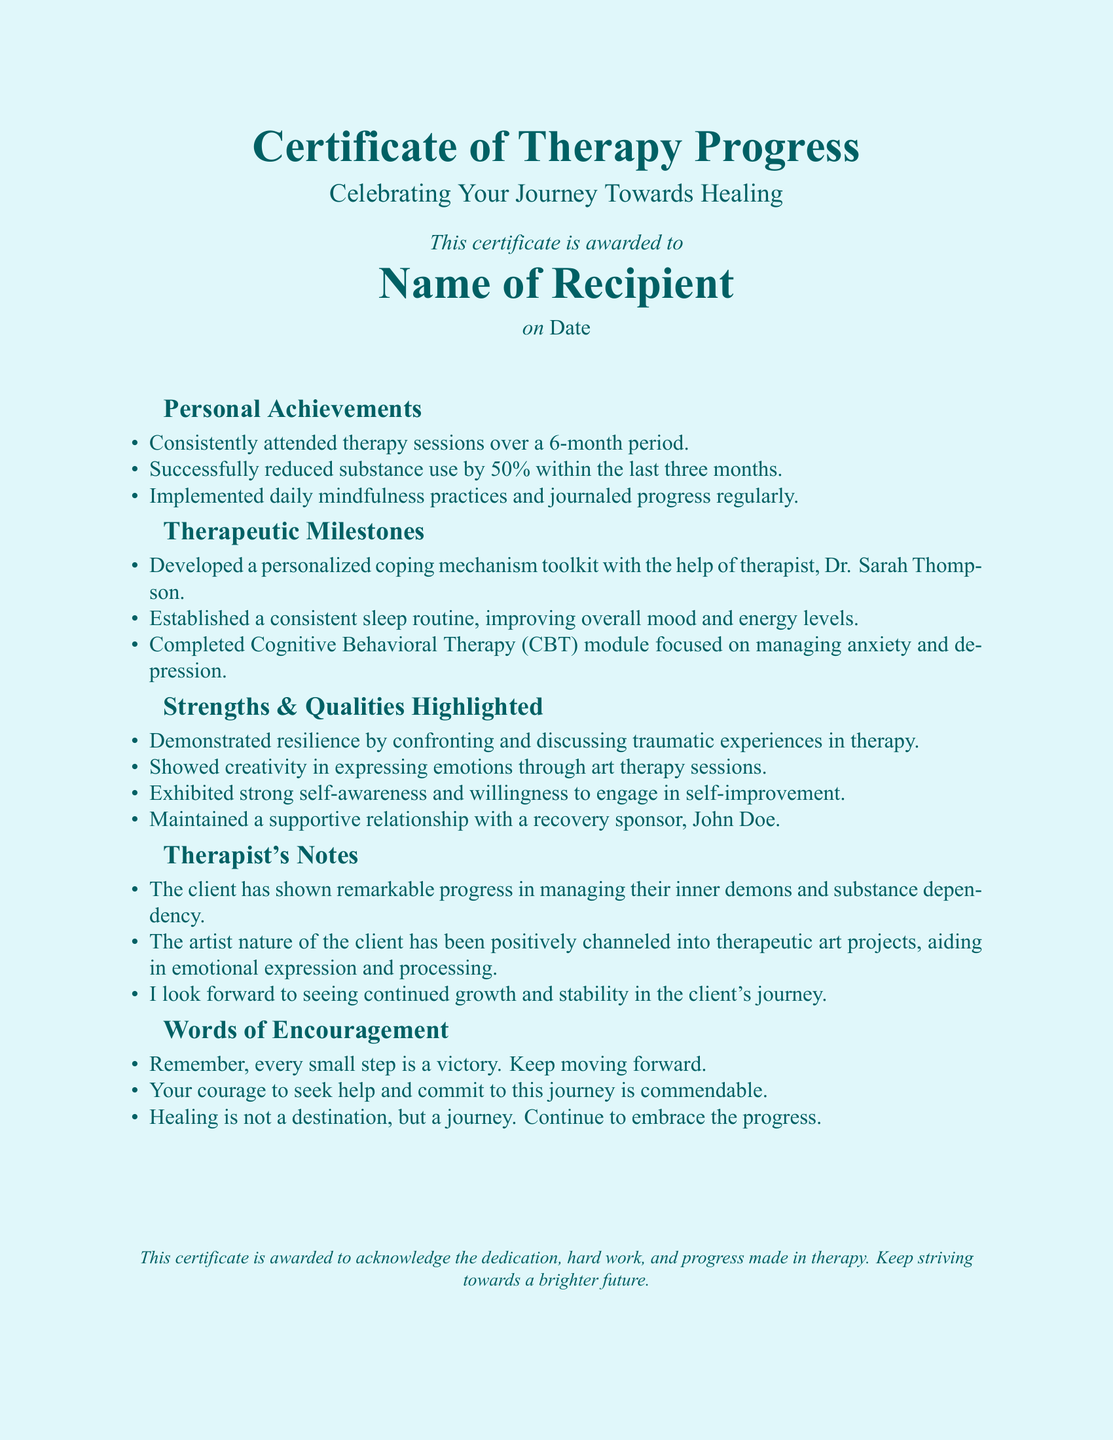What is the title of the certificate? The title of the certificate is presented prominently at the top of the document.
Answer: Certificate of Therapy Progress Who is the recipient of the certificate? The recipient's name is listed in the document under the awarding statement.
Answer: Name of Recipient On what date is the certificate awarded? The awarded date is specified in the document under the recipient's information.
Answer: Date How many months did the recipient consistently attend therapy sessions? The duration of attendance is mentioned in the 'Personal Achievements' section.
Answer: 6 By what percentage did the recipient successfully reduce substance use? The reduction percentage is stated in the 'Personal Achievements' section.
Answer: 50% Who is the therapist mentioned in the document? The therapist's name appears in the 'Therapeutic Milestones' section.
Answer: Dr. Sarah Thompson What type of therapy module did the recipient complete? The specific type of therapy module is given in the 'Therapeutic Milestones' section.
Answer: Cognitive Behavioral Therapy (CBT) What quality was highlighted regarding the client's creative abilities? The document mentions a specific way the recipient engaged their creativity.
Answer: Expressing emotions through art therapy sessions What is the main message conveyed in the 'Words of Encouragement' section? The main ideas in this section focus on the recipient's journey.
Answer: Healing is not a destination, but a journey 